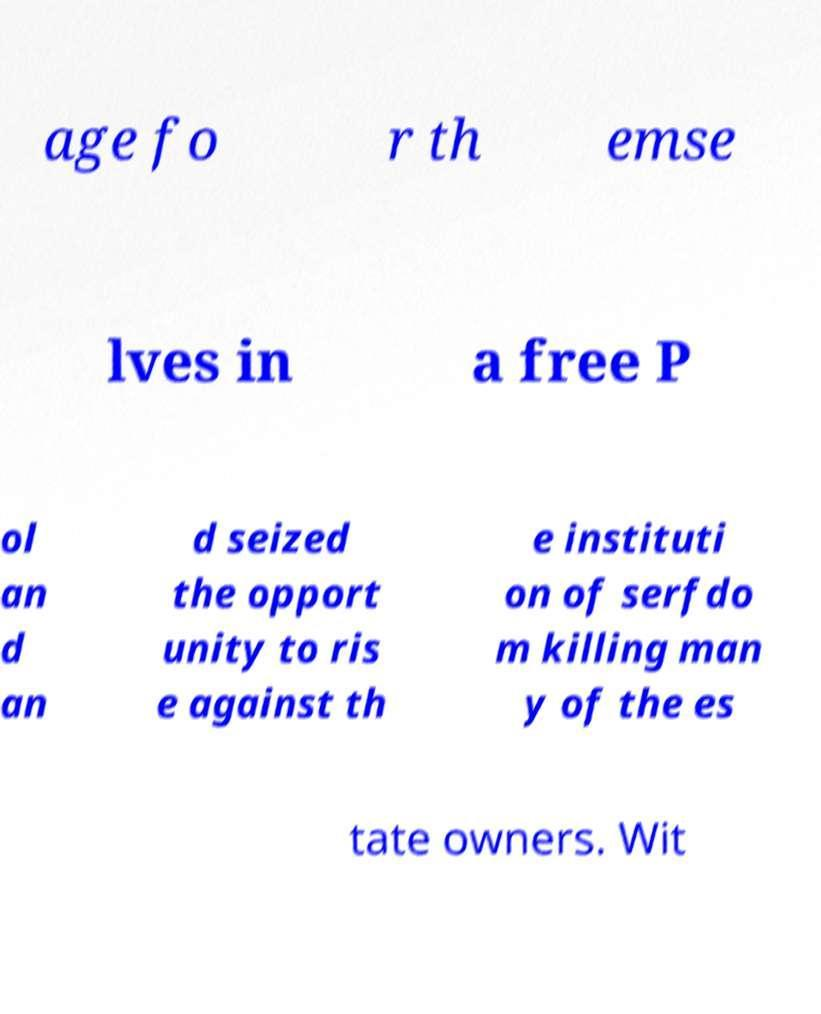Could you assist in decoding the text presented in this image and type it out clearly? age fo r th emse lves in a free P ol an d an d seized the opport unity to ris e against th e instituti on of serfdo m killing man y of the es tate owners. Wit 